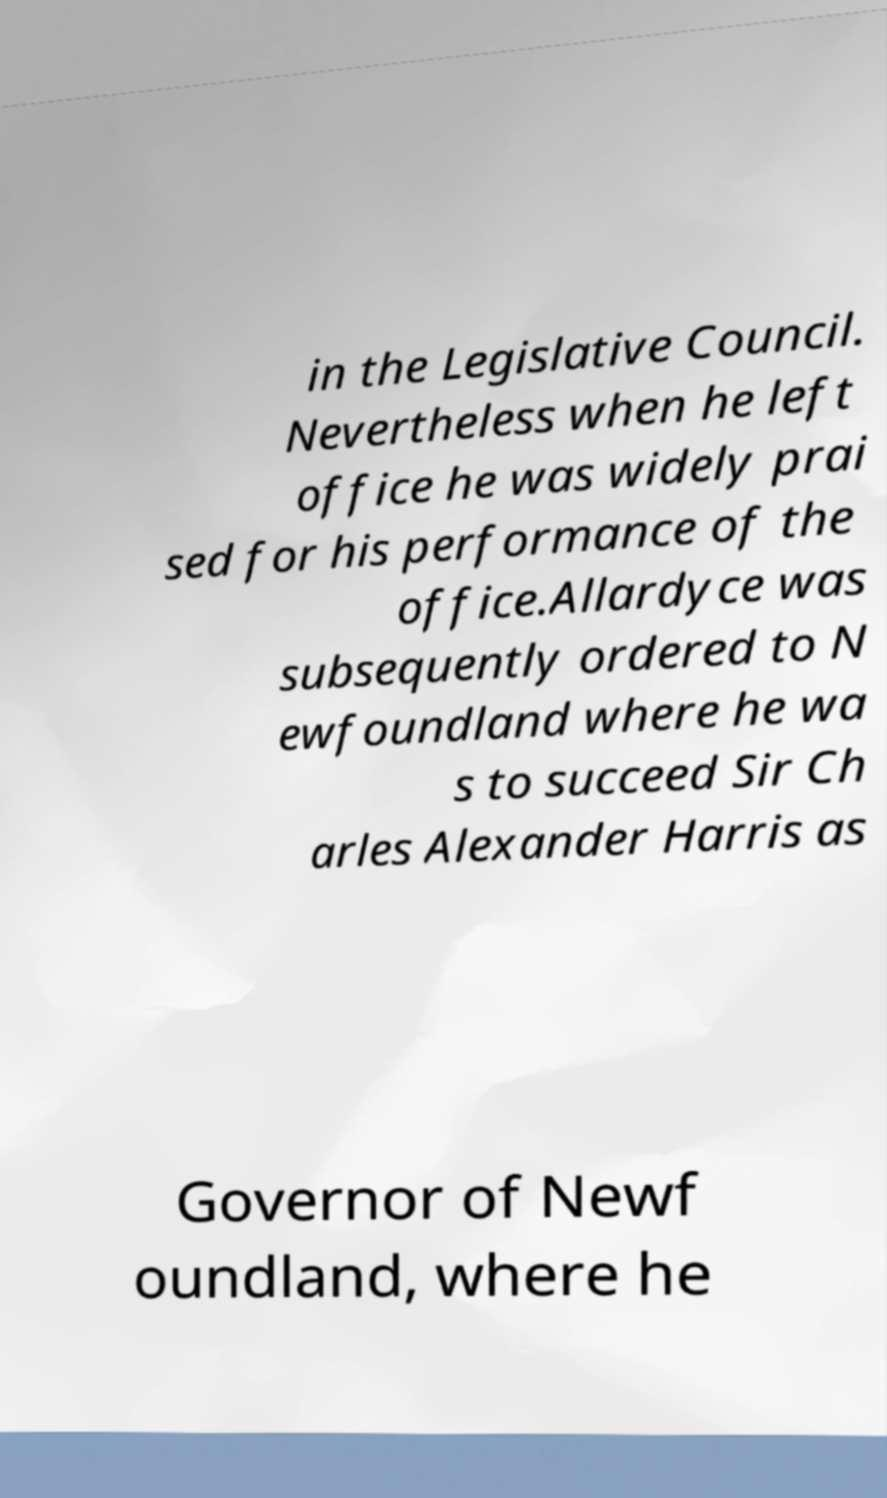There's text embedded in this image that I need extracted. Can you transcribe it verbatim? in the Legislative Council. Nevertheless when he left office he was widely prai sed for his performance of the office.Allardyce was subsequently ordered to N ewfoundland where he wa s to succeed Sir Ch arles Alexander Harris as Governor of Newf oundland, where he 